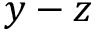<formula> <loc_0><loc_0><loc_500><loc_500>y - z</formula> 